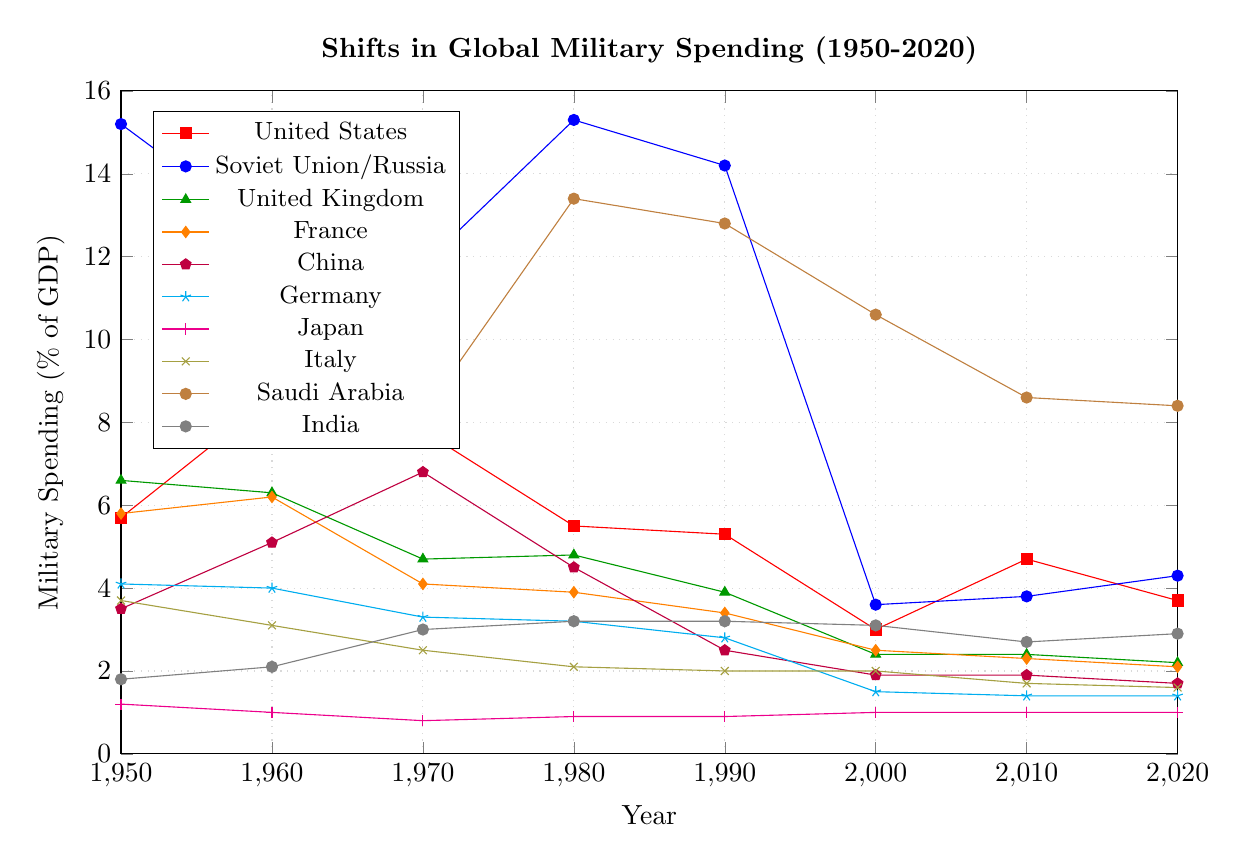Which country had the highest military spending as a percentage of GDP in 1950? From the figure, observe the height of the data points for each country in 1950. The Soviet Union/Russia has the highest data point among all countries.
Answer: Soviet Union/Russia What was the trend in military spending for the United States from 1950 to 2020? Follow the data points for the United States from 1950 to 2020 in the chart to observe the trend. Initially high, it peaked around 1960, then generally declined with some fluctuations, and finally settled lower than 1950 levels by 2020.
Answer: Generally declining with fluctuations Which country showed a significant increase in military spending between 1970 and 1980? Observe the differences in military spending percentages between 1970 and 1980 for each country. Saudi Arabia shows a noticeable increase from 8.2% to 13.4%.
Answer: Saudi Arabia In 1980, which country had the lowest military spending as a percentage of GDP and what was the percentage? Identify and compare the data points for all countries in 1980. Japan had the lowest military spending at 0.9%.
Answer: Japan, 0.9% Compare the military spending percentages of China and India in 2020. Which country spent more? Locate the data points for China and India in 2020 and compare their heights. India spent more with 2.9% compared to China’s 1.7%.
Answer: India What has been the trend in military spending for Germany from 1950 to 2020? Trace the data points for Germany from 1950 to 2020. The spending started relatively high and shows a consistent downward trend to a substantially lower level by 2020.
Answer: Consistently decreasing Calculate the average military spending as a percentage of GDP for France across all years shown. Sum the percentages for France across all listed years (5.8 + 6.2 + 4.1 + 3.9 + 3.4 + 2.5 + 2.3 + 2.1) and divide by the number of data points (8).
Answer: (5.8 + 6.2 + 4.1 + 3.9 + 3.4 + 2.5 + 2.3 + 2.1) / 8 = 3.53 During which decade did the United Kingdom see its most significant drop in military spending as a percentage of GDP? Observe the data points for the United Kingdom across all decades. The most significant drop is noticed between 1960 (6.3%) and 1970 (4.7%).
Answer: 1960-1970 What was the relative change in military spending for the Soviet Union/Russia from 1990 to 2000? Subtract the spending in 2000 (3.6%) from the spending in 1990 (14.2%) and calculate the relative change.
Answer: 14.2% - 3.6% = 10.6% Compare the military spending trends of Japan and Italy from 2000 to 2020. What is the key similarity? Observe the data points for Japan and Italy from 2000 to 2020. Both countries have almost stable military spending percentages with slight, gradual decreases.
Answer: Stable with slight decreases 